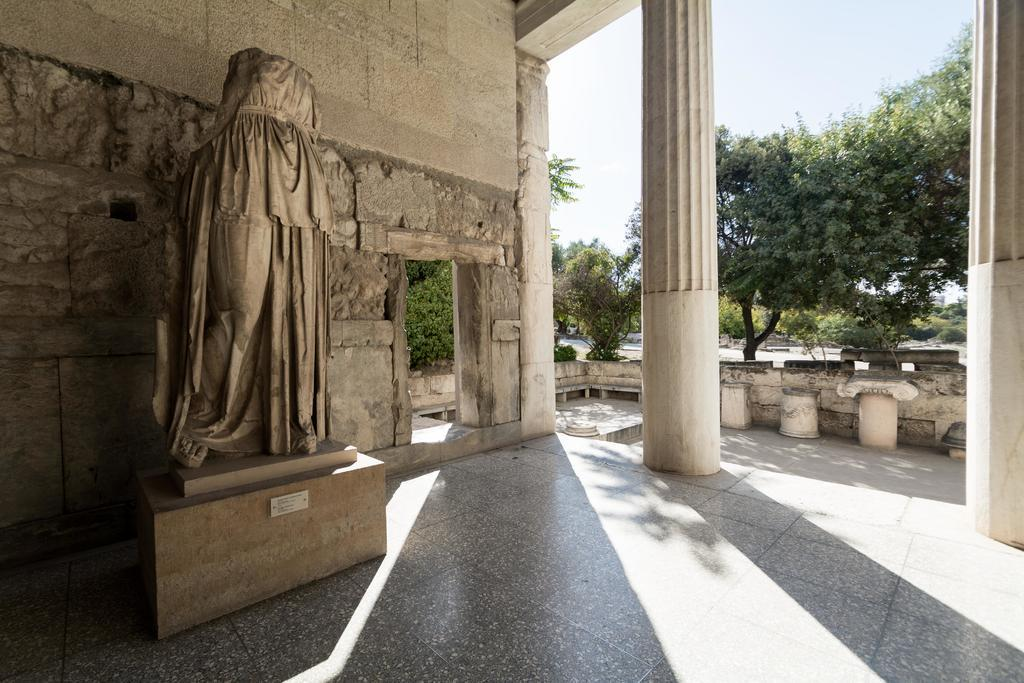What type of structure is present in the image? There is a building in the image. What architectural features can be seen on the building? There are pillars visible on the building. What type of natural vegetation is present in the image? There are trees in the image. What is visible in the background of the image? The sky is visible in the background of the image. Can you see a swing hanging from the trees in the image? There is no swing present in the image; only the building, pillars, trees, and sky are visible. Is there a body of water visible in the image? There is no body of water present in the image. 